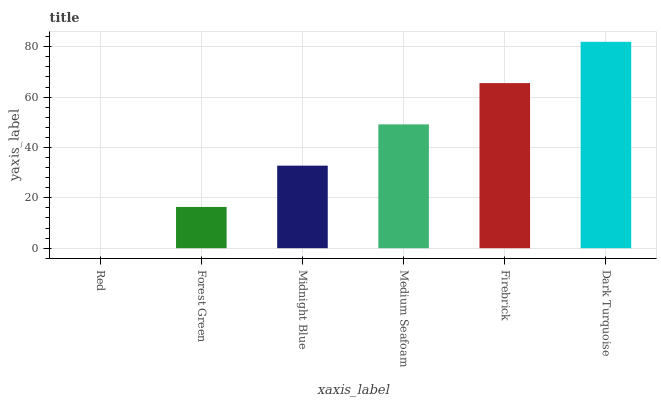Is Forest Green the minimum?
Answer yes or no. No. Is Forest Green the maximum?
Answer yes or no. No. Is Forest Green greater than Red?
Answer yes or no. Yes. Is Red less than Forest Green?
Answer yes or no. Yes. Is Red greater than Forest Green?
Answer yes or no. No. Is Forest Green less than Red?
Answer yes or no. No. Is Medium Seafoam the high median?
Answer yes or no. Yes. Is Midnight Blue the low median?
Answer yes or no. Yes. Is Dark Turquoise the high median?
Answer yes or no. No. Is Forest Green the low median?
Answer yes or no. No. 